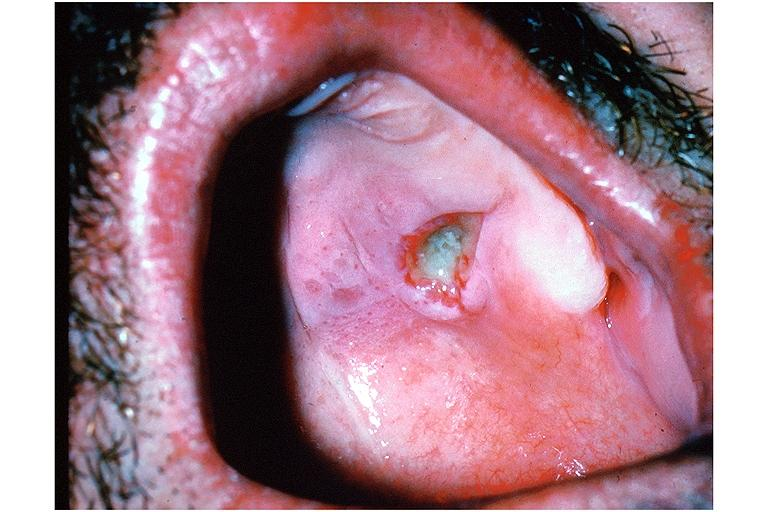where is this?
Answer the question using a single word or phrase. Oral 